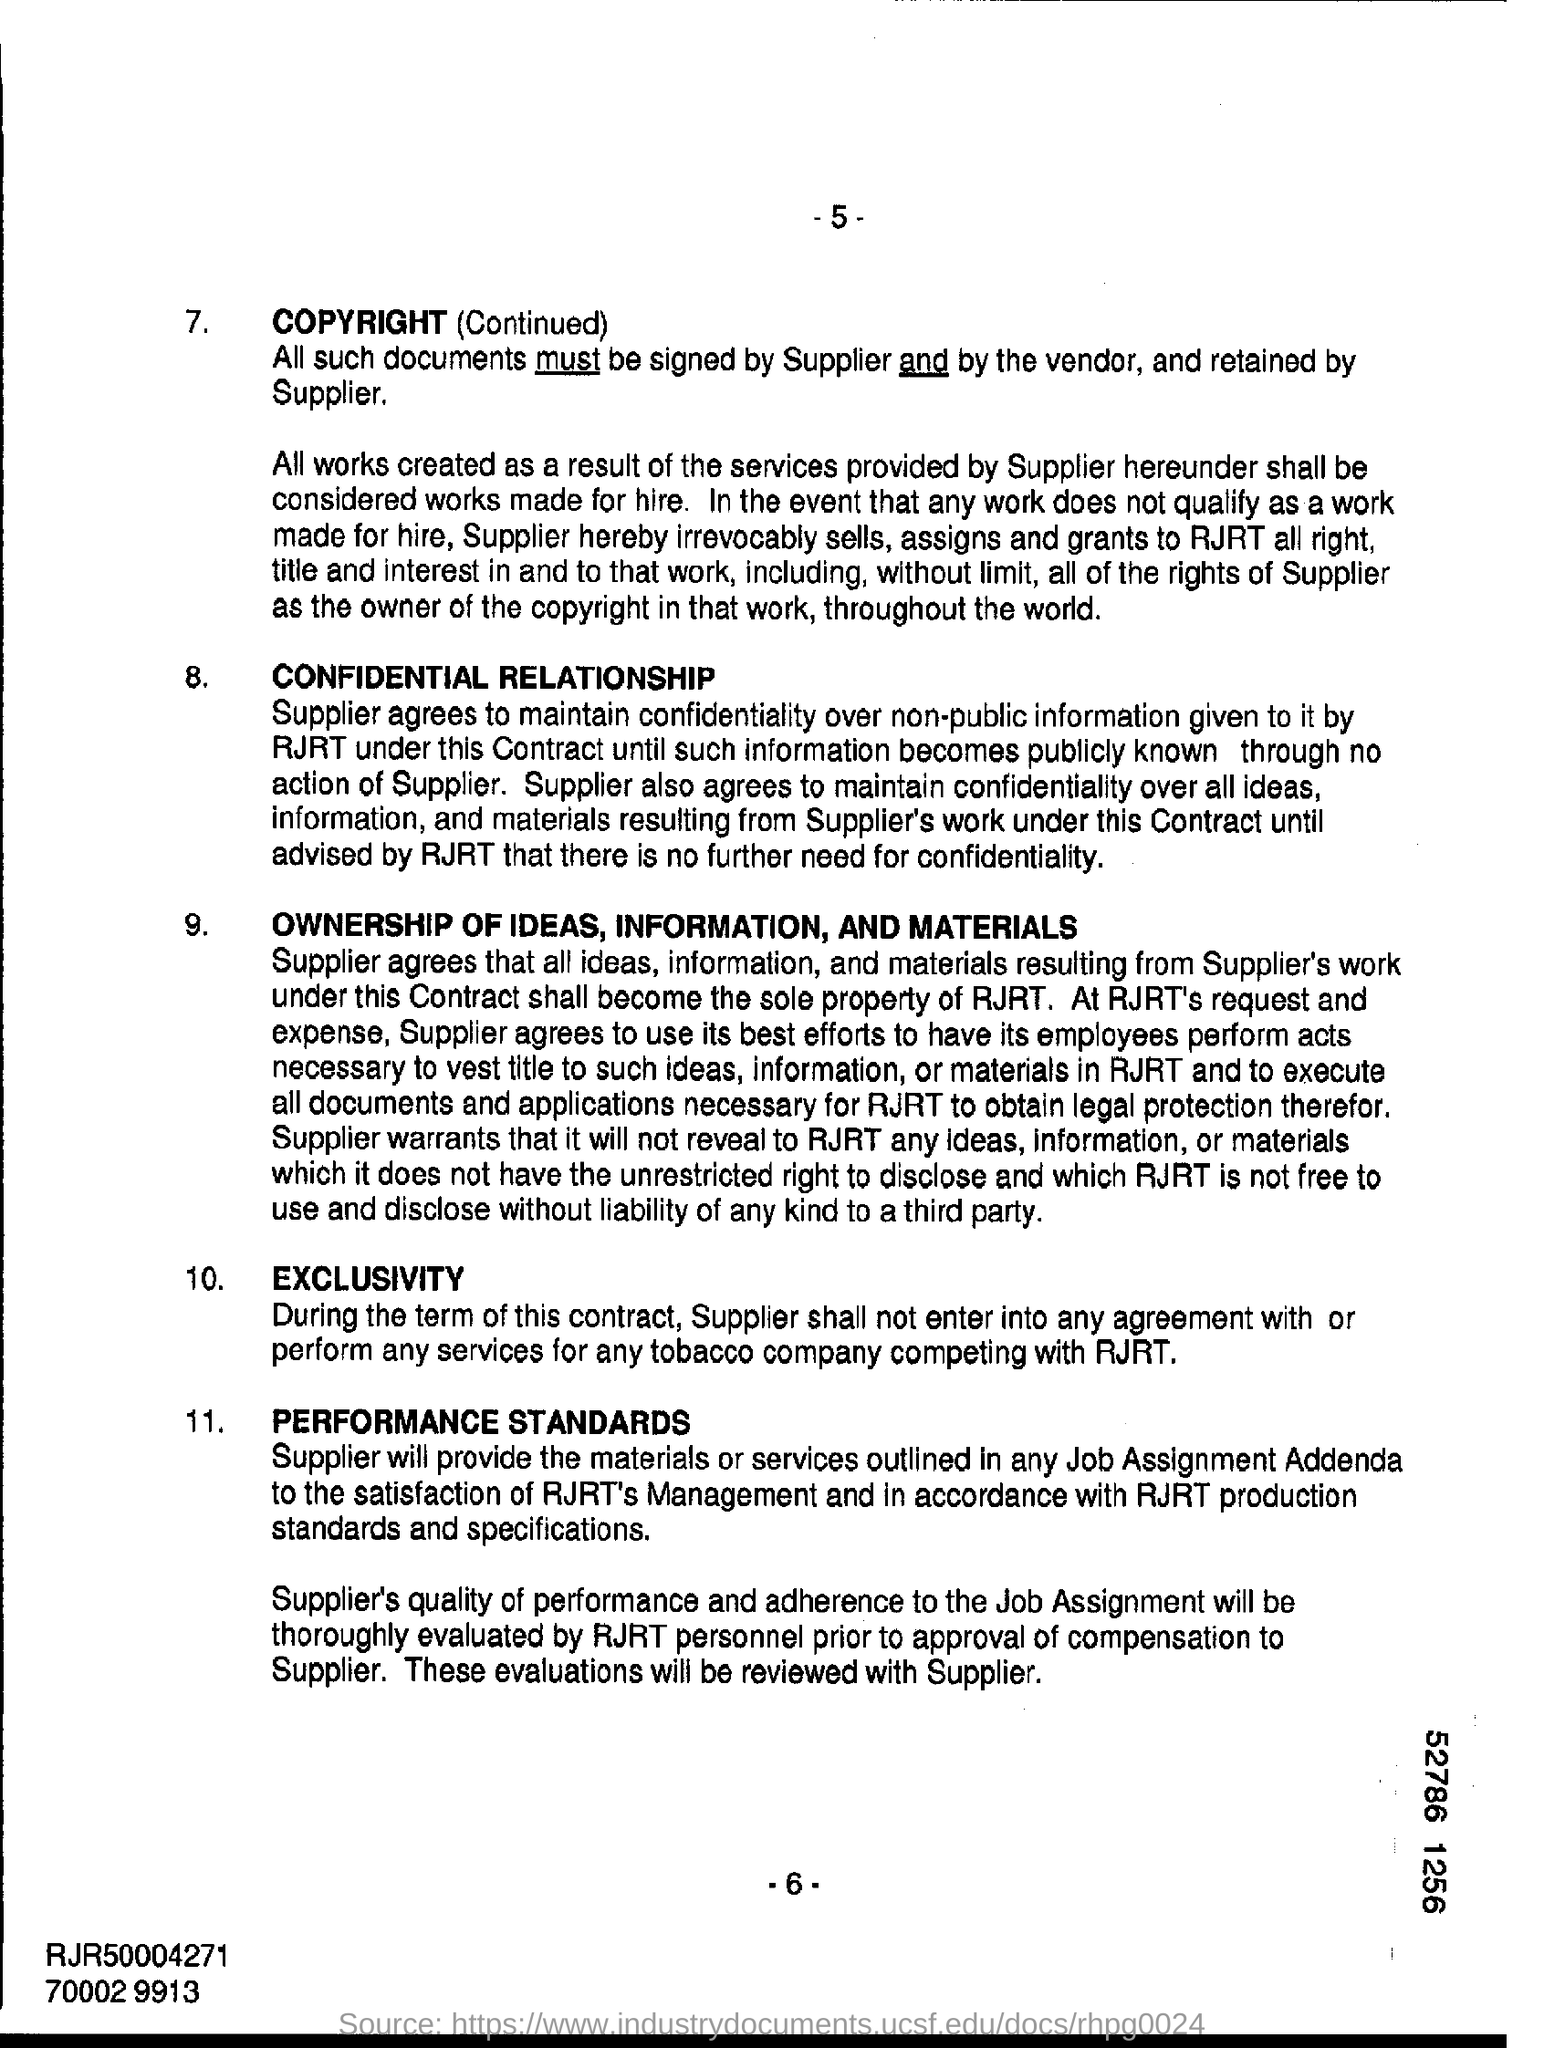Indicate a few pertinent items in this graphic. The documents must be signed by both the supplier and the vendor. The page number mentioned in this document is -6-. 